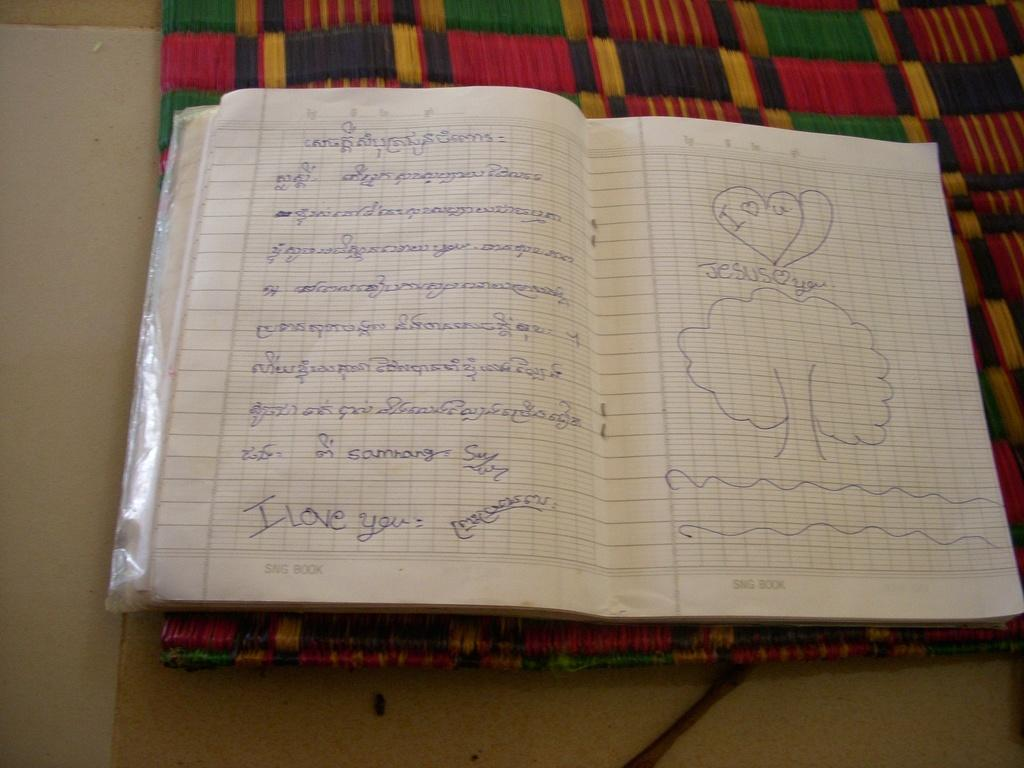Provide a one-sentence caption for the provided image. Notebook with I love you and Jesus love you wrote on the pages. 